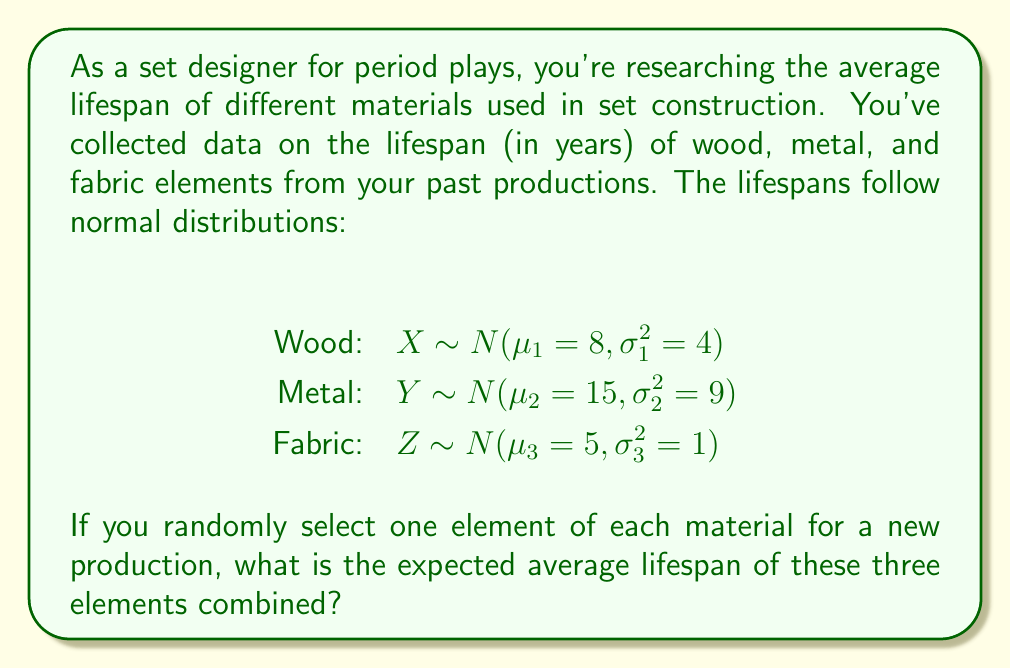Could you help me with this problem? To solve this problem, we need to follow these steps:

1. Identify the random variable: Let $W$ be the average lifespan of the three randomly selected elements.

2. Express $W$ in terms of $X$, $Y$, and $Z$:
   $W = \frac{X + Y + Z}{3}$

3. Calculate the expected value of $W$:
   $E[W] = E[\frac{X + Y + Z}{3}]$

4. Use the linearity of expectation:
   $E[W] = \frac{E[X] + E[Y] + E[Z]}{3}$

5. Recall that for a normal distribution $N(\mu, \sigma^2)$, the expected value is $\mu$:
   $E[X] = \mu_1 = 8$
   $E[Y] = \mu_2 = 15$
   $E[Z] = \mu_3 = 5$

6. Substitute these values into the equation:
   $E[W] = \frac{8 + 15 + 5}{3} = \frac{28}{3}$

7. Compute the final result:
   $E[W] = \frac{28}{3} \approx 9.33$ years

Therefore, the expected average lifespan of the three randomly selected elements is approximately 9.33 years.
Answer: $\frac{28}{3} \approx 9.33$ years 